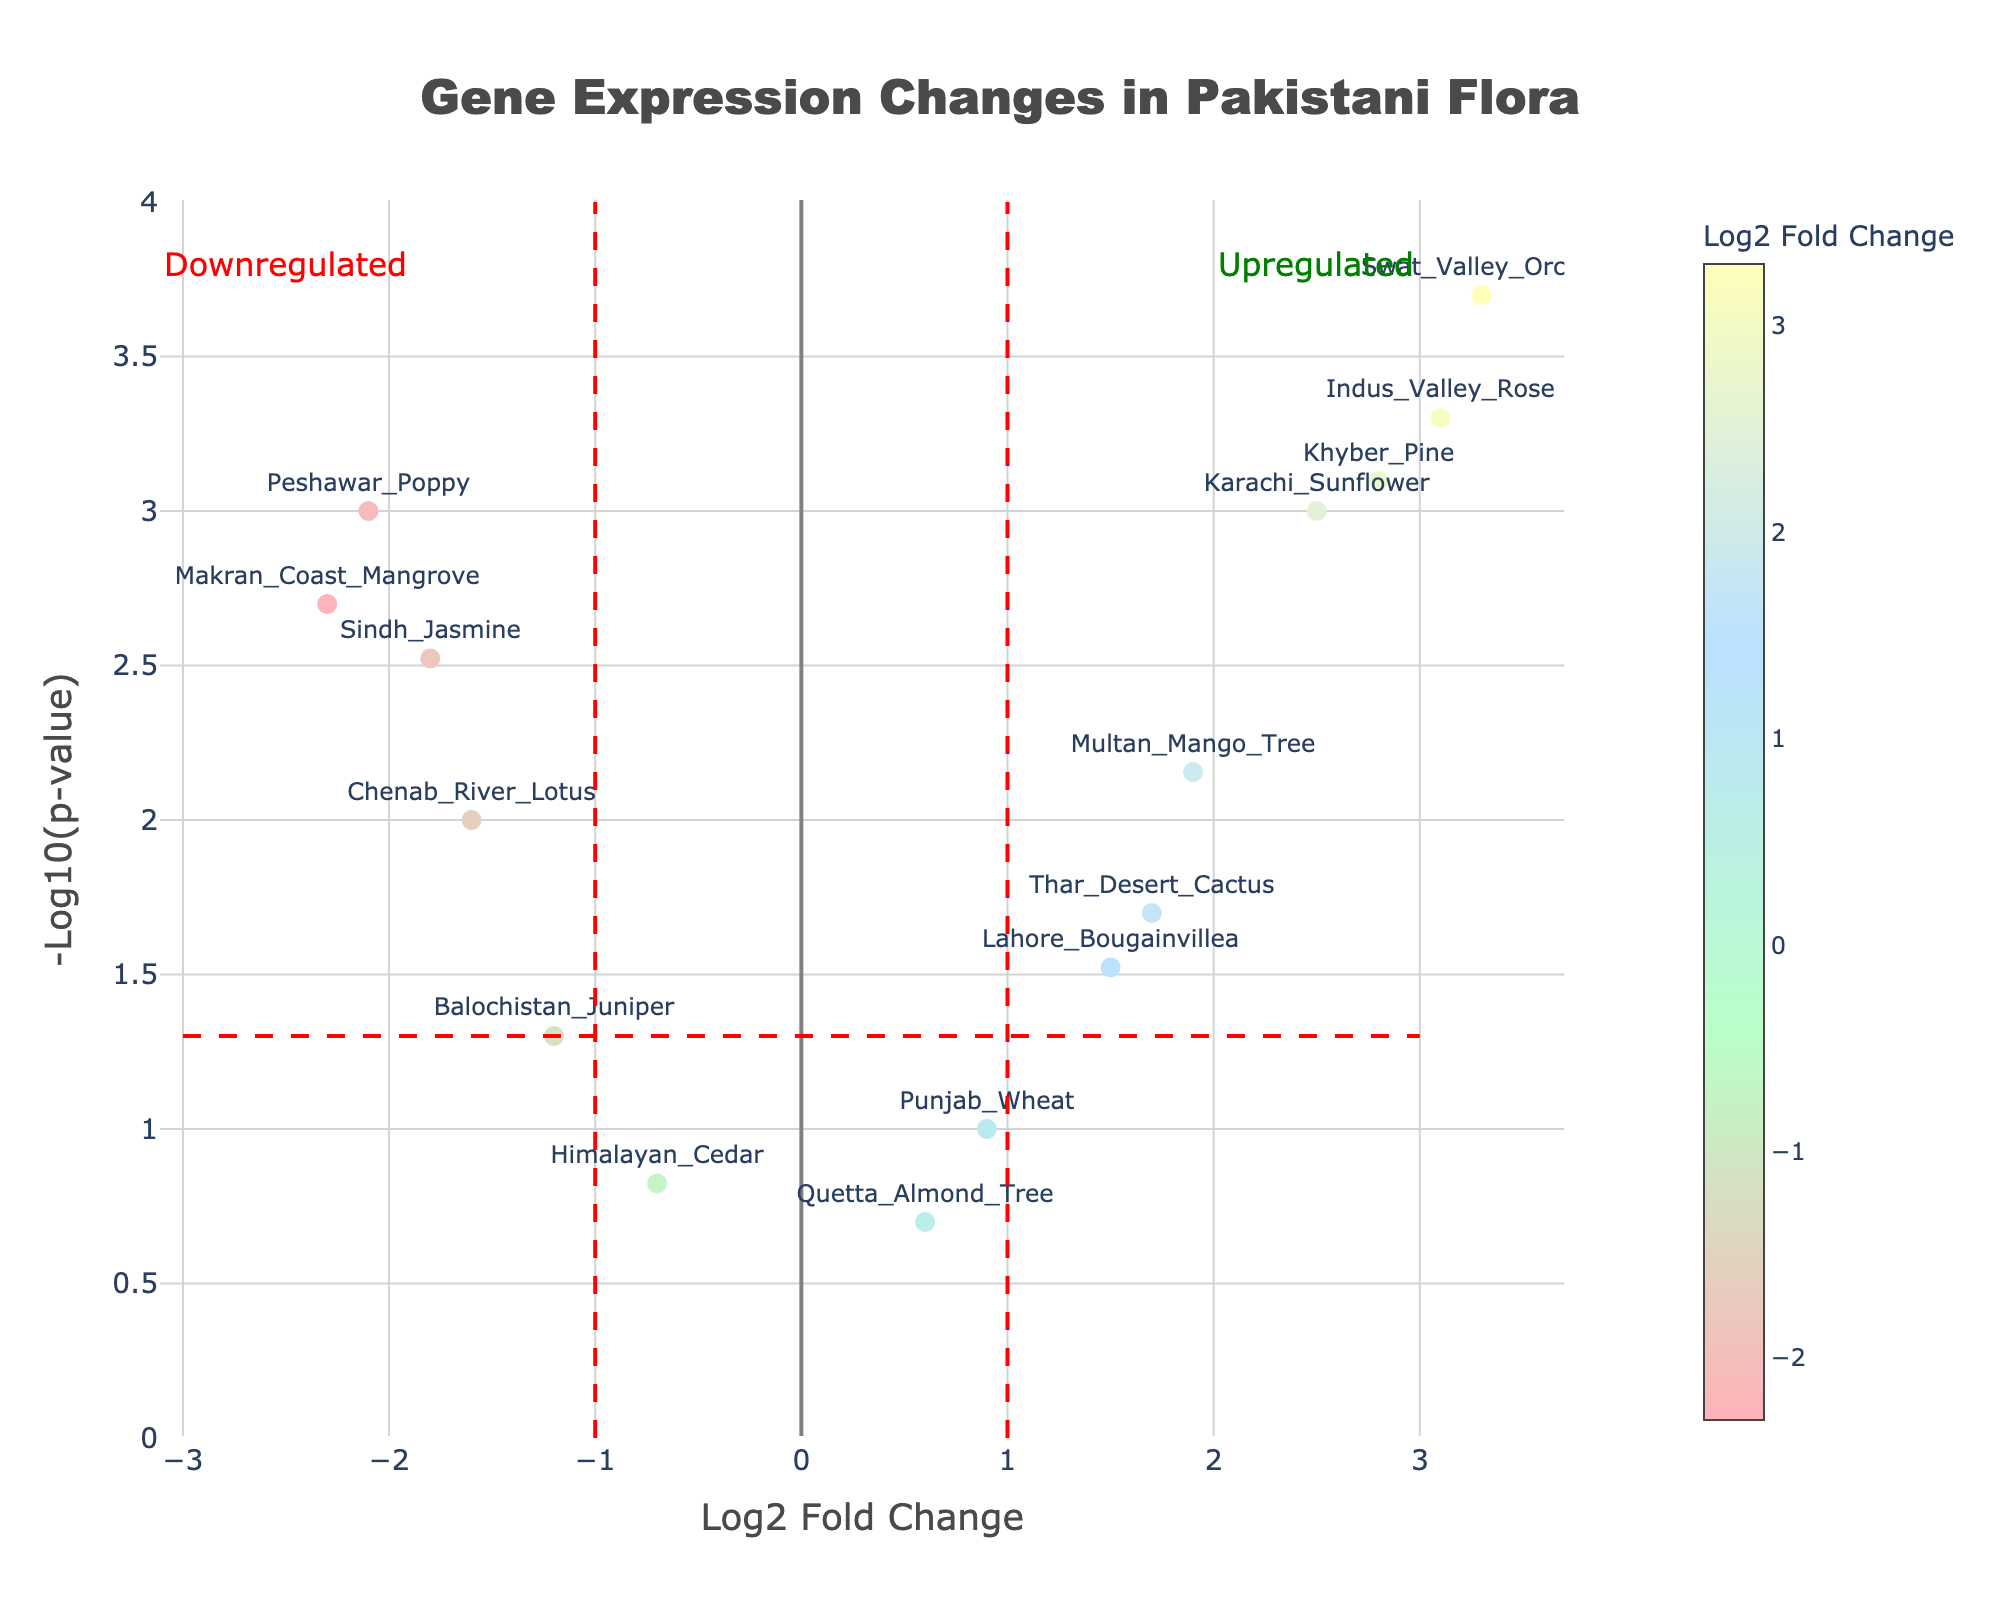Which gene shows the highest level of upregulation? To identify the highest level of upregulation, look at the vertical position on the x-axis for the highest positive log2 fold change. The gene with the highest log2 fold change value is Swat_Valley_Orchid, with a value of 3.3.
Answer: Swat_Valley_Orchid Which gene has the smallest p-value? The smallest p-value corresponds to the highest -log10(p-value) on the y-axis. The gene with the highest -log10(p-value) value is Swat_Valley_Orchid, indicating that it has the smallest p-value.
Answer: Swat_Valley_Orchid How many genes are significantly upregulated (log2 fold change > 1 and p-value < 0.05)? Count the data points falling to the right of the vertical line at log2 fold change > 1 and above the horizontal line at -log10(p-value) > 1.3 (i.e., p-value < 0.05). The significantly upregulated genes are Karachi_Sunflower, Indus_Valley_Rose, Khyber_Pine, Swat_Valley_Orchid, and Multan_Mango_Tree, totaling 5 genes.
Answer: 5 Which gene displays the highest level of downregulation? Identify the lowest (most negative) log2 fold change value. The gene with the most negative log2 fold change value is Makran_Coast_Mangrove, with a value of -2.3.
Answer: Makran_Coast_Mangrove Does Lahore_Bougainvillea meet the criteria for significant changes in expression? Check if Lahore_Bougainvillea meets the criteria of log2 fold change greater than 1 or less than -1 and p-value < 0.05. Lahore_Bougainvillea has a log2 fold change of 1.5 and a p-value of 0.03, meaning it meets both criteria.
Answer: Yes Are there more upregulated or downregulated genes if we consider only genes with p-value < 0.01? Count the upregulated genes (log2 fold change > 0) and downregulated genes (log2 fold change < 0) with p-value < 0.01. Upregulated genes: Karachi_Sunflower, Indus_Valley_Rose, Khyber_Pine, Swat_Valley_Orchid, Multan_Mango_Tree. Downregulated genes: Sindh_Jasmine, Makran_Coast_Mangrove, Peshawar_Poppy, Chenab_River_Lotus. There are 5 upregulated genes and 4 downregulated genes.
Answer: More upregulated Which gene has the closest log2 fold change to 1.0? Identify the gene whose log2 fold change value is closest to 1.0. Lahore_Bougainvillea has the closest value with a log2 fold change of 1.5.
Answer: Lahore_Bougainvillea If we categorize significant genes based on log2 fold change criteria of >2 and <-2, how many genes fall into "highly upregulated" and "highly downregulated" categories? Count the genes with log2 fold change > 2 for "highly upregulated" and log2 fold change < -2 for "highly downregulated" with p-value < 0.05. Highly upregulated genes: Karachi_Sunflower, Indus_Valley_Rose, Khyber_Pine, Swat_Valley_Orchid. Highly downregulated genes: Makran_Coast_Mangrove, Peshawar_Poppy. Thus, there are 4 highly upregulated and 2 highly downregulated genes.
Answer: 4 highly upregulated, 2 highly downregulated 